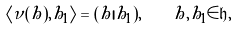Convert formula to latex. <formula><loc_0><loc_0><loc_500><loc_500>\langle \nu ( h ) , h _ { 1 } \rangle = ( h | h _ { 1 } ) , \quad h , h _ { 1 } \in \mathfrak { h } ,</formula> 